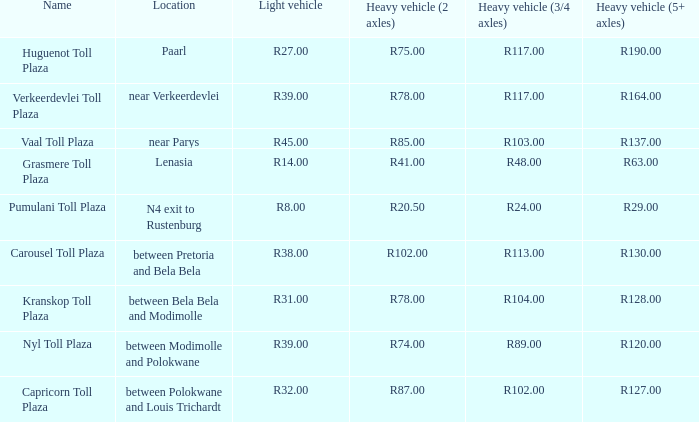Help me parse the entirety of this table. {'header': ['Name', 'Location', 'Light vehicle', 'Heavy vehicle (2 axles)', 'Heavy vehicle (3/4 axles)', 'Heavy vehicle (5+ axles)'], 'rows': [['Huguenot Toll Plaza', 'Paarl', 'R27.00', 'R75.00', 'R117.00', 'R190.00'], ['Verkeerdevlei Toll Plaza', 'near Verkeerdevlei', 'R39.00', 'R78.00', 'R117.00', 'R164.00'], ['Vaal Toll Plaza', 'near Parys', 'R45.00', 'R85.00', 'R103.00', 'R137.00'], ['Grasmere Toll Plaza', 'Lenasia', 'R14.00', 'R41.00', 'R48.00', 'R63.00'], ['Pumulani Toll Plaza', 'N4 exit to Rustenburg', 'R8.00', 'R20.50', 'R24.00', 'R29.00'], ['Carousel Toll Plaza', 'between Pretoria and Bela Bela', 'R38.00', 'R102.00', 'R113.00', 'R130.00'], ['Kranskop Toll Plaza', 'between Bela Bela and Modimolle', 'R31.00', 'R78.00', 'R104.00', 'R128.00'], ['Nyl Toll Plaza', 'between Modimolle and Polokwane', 'R39.00', 'R74.00', 'R89.00', 'R120.00'], ['Capricorn Toll Plaza', 'between Polokwane and Louis Trichardt', 'R32.00', 'R87.00', 'R102.00', 'R127.00']]} What is the name of the plaza where the toll for heavy vehicles with 2 axles is r87.00? Capricorn Toll Plaza. 